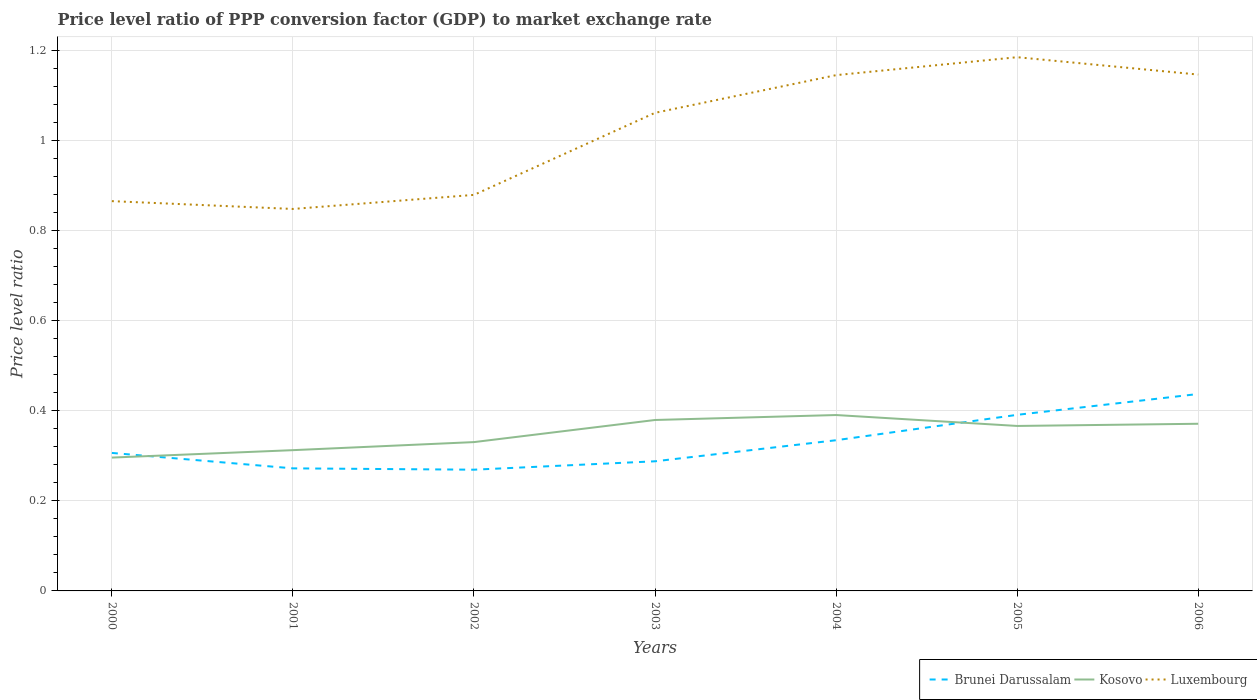Does the line corresponding to Kosovo intersect with the line corresponding to Brunei Darussalam?
Offer a terse response. Yes. Across all years, what is the maximum price level ratio in Luxembourg?
Give a very brief answer. 0.85. In which year was the price level ratio in Kosovo maximum?
Your answer should be compact. 2000. What is the total price level ratio in Kosovo in the graph?
Offer a very short reply. -0.03. What is the difference between the highest and the second highest price level ratio in Brunei Darussalam?
Make the answer very short. 0.17. What is the difference between the highest and the lowest price level ratio in Brunei Darussalam?
Ensure brevity in your answer.  3. Is the price level ratio in Luxembourg strictly greater than the price level ratio in Brunei Darussalam over the years?
Offer a very short reply. No. How many lines are there?
Offer a very short reply. 3. How many years are there in the graph?
Provide a short and direct response. 7. Where does the legend appear in the graph?
Make the answer very short. Bottom right. How are the legend labels stacked?
Offer a very short reply. Horizontal. What is the title of the graph?
Give a very brief answer. Price level ratio of PPP conversion factor (GDP) to market exchange rate. What is the label or title of the Y-axis?
Your answer should be compact. Price level ratio. What is the Price level ratio in Brunei Darussalam in 2000?
Make the answer very short. 0.31. What is the Price level ratio in Kosovo in 2000?
Make the answer very short. 0.3. What is the Price level ratio of Luxembourg in 2000?
Provide a short and direct response. 0.87. What is the Price level ratio in Brunei Darussalam in 2001?
Your answer should be very brief. 0.27. What is the Price level ratio in Kosovo in 2001?
Give a very brief answer. 0.31. What is the Price level ratio in Luxembourg in 2001?
Provide a succinct answer. 0.85. What is the Price level ratio of Brunei Darussalam in 2002?
Give a very brief answer. 0.27. What is the Price level ratio of Kosovo in 2002?
Your response must be concise. 0.33. What is the Price level ratio of Luxembourg in 2002?
Offer a terse response. 0.88. What is the Price level ratio of Brunei Darussalam in 2003?
Keep it short and to the point. 0.29. What is the Price level ratio of Kosovo in 2003?
Keep it short and to the point. 0.38. What is the Price level ratio of Luxembourg in 2003?
Ensure brevity in your answer.  1.06. What is the Price level ratio of Brunei Darussalam in 2004?
Keep it short and to the point. 0.33. What is the Price level ratio of Kosovo in 2004?
Your answer should be compact. 0.39. What is the Price level ratio of Luxembourg in 2004?
Offer a terse response. 1.15. What is the Price level ratio of Brunei Darussalam in 2005?
Keep it short and to the point. 0.39. What is the Price level ratio of Kosovo in 2005?
Offer a terse response. 0.37. What is the Price level ratio of Luxembourg in 2005?
Make the answer very short. 1.19. What is the Price level ratio in Brunei Darussalam in 2006?
Your answer should be very brief. 0.44. What is the Price level ratio in Kosovo in 2006?
Give a very brief answer. 0.37. What is the Price level ratio in Luxembourg in 2006?
Offer a very short reply. 1.15. Across all years, what is the maximum Price level ratio of Brunei Darussalam?
Provide a succinct answer. 0.44. Across all years, what is the maximum Price level ratio in Kosovo?
Your response must be concise. 0.39. Across all years, what is the maximum Price level ratio of Luxembourg?
Provide a short and direct response. 1.19. Across all years, what is the minimum Price level ratio in Brunei Darussalam?
Give a very brief answer. 0.27. Across all years, what is the minimum Price level ratio in Kosovo?
Give a very brief answer. 0.3. Across all years, what is the minimum Price level ratio in Luxembourg?
Provide a short and direct response. 0.85. What is the total Price level ratio in Brunei Darussalam in the graph?
Make the answer very short. 2.3. What is the total Price level ratio in Kosovo in the graph?
Your answer should be very brief. 2.45. What is the total Price level ratio of Luxembourg in the graph?
Give a very brief answer. 7.13. What is the difference between the Price level ratio in Brunei Darussalam in 2000 and that in 2001?
Your response must be concise. 0.03. What is the difference between the Price level ratio in Kosovo in 2000 and that in 2001?
Keep it short and to the point. -0.02. What is the difference between the Price level ratio in Luxembourg in 2000 and that in 2001?
Your response must be concise. 0.02. What is the difference between the Price level ratio in Brunei Darussalam in 2000 and that in 2002?
Your response must be concise. 0.04. What is the difference between the Price level ratio in Kosovo in 2000 and that in 2002?
Your answer should be very brief. -0.03. What is the difference between the Price level ratio of Luxembourg in 2000 and that in 2002?
Your answer should be compact. -0.01. What is the difference between the Price level ratio in Brunei Darussalam in 2000 and that in 2003?
Your answer should be very brief. 0.02. What is the difference between the Price level ratio of Kosovo in 2000 and that in 2003?
Make the answer very short. -0.08. What is the difference between the Price level ratio in Luxembourg in 2000 and that in 2003?
Your answer should be very brief. -0.2. What is the difference between the Price level ratio in Brunei Darussalam in 2000 and that in 2004?
Your response must be concise. -0.03. What is the difference between the Price level ratio in Kosovo in 2000 and that in 2004?
Ensure brevity in your answer.  -0.09. What is the difference between the Price level ratio of Luxembourg in 2000 and that in 2004?
Ensure brevity in your answer.  -0.28. What is the difference between the Price level ratio of Brunei Darussalam in 2000 and that in 2005?
Your answer should be very brief. -0.08. What is the difference between the Price level ratio in Kosovo in 2000 and that in 2005?
Your answer should be very brief. -0.07. What is the difference between the Price level ratio of Luxembourg in 2000 and that in 2005?
Your answer should be compact. -0.32. What is the difference between the Price level ratio of Brunei Darussalam in 2000 and that in 2006?
Offer a very short reply. -0.13. What is the difference between the Price level ratio in Kosovo in 2000 and that in 2006?
Provide a succinct answer. -0.08. What is the difference between the Price level ratio of Luxembourg in 2000 and that in 2006?
Provide a short and direct response. -0.28. What is the difference between the Price level ratio of Brunei Darussalam in 2001 and that in 2002?
Offer a terse response. 0. What is the difference between the Price level ratio in Kosovo in 2001 and that in 2002?
Your response must be concise. -0.02. What is the difference between the Price level ratio of Luxembourg in 2001 and that in 2002?
Offer a terse response. -0.03. What is the difference between the Price level ratio in Brunei Darussalam in 2001 and that in 2003?
Provide a short and direct response. -0.02. What is the difference between the Price level ratio of Kosovo in 2001 and that in 2003?
Provide a succinct answer. -0.07. What is the difference between the Price level ratio in Luxembourg in 2001 and that in 2003?
Ensure brevity in your answer.  -0.21. What is the difference between the Price level ratio in Brunei Darussalam in 2001 and that in 2004?
Offer a terse response. -0.06. What is the difference between the Price level ratio of Kosovo in 2001 and that in 2004?
Give a very brief answer. -0.08. What is the difference between the Price level ratio of Luxembourg in 2001 and that in 2004?
Offer a terse response. -0.3. What is the difference between the Price level ratio of Brunei Darussalam in 2001 and that in 2005?
Ensure brevity in your answer.  -0.12. What is the difference between the Price level ratio in Kosovo in 2001 and that in 2005?
Your answer should be very brief. -0.05. What is the difference between the Price level ratio in Luxembourg in 2001 and that in 2005?
Your answer should be very brief. -0.34. What is the difference between the Price level ratio in Brunei Darussalam in 2001 and that in 2006?
Offer a terse response. -0.17. What is the difference between the Price level ratio of Kosovo in 2001 and that in 2006?
Provide a short and direct response. -0.06. What is the difference between the Price level ratio in Luxembourg in 2001 and that in 2006?
Ensure brevity in your answer.  -0.3. What is the difference between the Price level ratio in Brunei Darussalam in 2002 and that in 2003?
Make the answer very short. -0.02. What is the difference between the Price level ratio of Kosovo in 2002 and that in 2003?
Keep it short and to the point. -0.05. What is the difference between the Price level ratio in Luxembourg in 2002 and that in 2003?
Your response must be concise. -0.18. What is the difference between the Price level ratio in Brunei Darussalam in 2002 and that in 2004?
Provide a succinct answer. -0.07. What is the difference between the Price level ratio in Kosovo in 2002 and that in 2004?
Your answer should be very brief. -0.06. What is the difference between the Price level ratio in Luxembourg in 2002 and that in 2004?
Keep it short and to the point. -0.27. What is the difference between the Price level ratio in Brunei Darussalam in 2002 and that in 2005?
Provide a short and direct response. -0.12. What is the difference between the Price level ratio of Kosovo in 2002 and that in 2005?
Keep it short and to the point. -0.04. What is the difference between the Price level ratio of Luxembourg in 2002 and that in 2005?
Give a very brief answer. -0.31. What is the difference between the Price level ratio in Brunei Darussalam in 2002 and that in 2006?
Provide a succinct answer. -0.17. What is the difference between the Price level ratio of Kosovo in 2002 and that in 2006?
Offer a very short reply. -0.04. What is the difference between the Price level ratio of Luxembourg in 2002 and that in 2006?
Keep it short and to the point. -0.27. What is the difference between the Price level ratio of Brunei Darussalam in 2003 and that in 2004?
Ensure brevity in your answer.  -0.05. What is the difference between the Price level ratio in Kosovo in 2003 and that in 2004?
Ensure brevity in your answer.  -0.01. What is the difference between the Price level ratio of Luxembourg in 2003 and that in 2004?
Keep it short and to the point. -0.08. What is the difference between the Price level ratio in Brunei Darussalam in 2003 and that in 2005?
Offer a terse response. -0.1. What is the difference between the Price level ratio of Kosovo in 2003 and that in 2005?
Provide a short and direct response. 0.01. What is the difference between the Price level ratio of Luxembourg in 2003 and that in 2005?
Keep it short and to the point. -0.12. What is the difference between the Price level ratio in Brunei Darussalam in 2003 and that in 2006?
Make the answer very short. -0.15. What is the difference between the Price level ratio in Kosovo in 2003 and that in 2006?
Your answer should be very brief. 0.01. What is the difference between the Price level ratio in Luxembourg in 2003 and that in 2006?
Provide a short and direct response. -0.09. What is the difference between the Price level ratio of Brunei Darussalam in 2004 and that in 2005?
Offer a very short reply. -0.06. What is the difference between the Price level ratio of Kosovo in 2004 and that in 2005?
Give a very brief answer. 0.02. What is the difference between the Price level ratio in Luxembourg in 2004 and that in 2005?
Make the answer very short. -0.04. What is the difference between the Price level ratio in Brunei Darussalam in 2004 and that in 2006?
Make the answer very short. -0.1. What is the difference between the Price level ratio of Kosovo in 2004 and that in 2006?
Ensure brevity in your answer.  0.02. What is the difference between the Price level ratio in Luxembourg in 2004 and that in 2006?
Offer a terse response. -0. What is the difference between the Price level ratio of Brunei Darussalam in 2005 and that in 2006?
Your answer should be compact. -0.05. What is the difference between the Price level ratio in Kosovo in 2005 and that in 2006?
Your response must be concise. -0. What is the difference between the Price level ratio in Luxembourg in 2005 and that in 2006?
Your response must be concise. 0.04. What is the difference between the Price level ratio in Brunei Darussalam in 2000 and the Price level ratio in Kosovo in 2001?
Provide a succinct answer. -0.01. What is the difference between the Price level ratio in Brunei Darussalam in 2000 and the Price level ratio in Luxembourg in 2001?
Your response must be concise. -0.54. What is the difference between the Price level ratio in Kosovo in 2000 and the Price level ratio in Luxembourg in 2001?
Offer a very short reply. -0.55. What is the difference between the Price level ratio in Brunei Darussalam in 2000 and the Price level ratio in Kosovo in 2002?
Your response must be concise. -0.02. What is the difference between the Price level ratio in Brunei Darussalam in 2000 and the Price level ratio in Luxembourg in 2002?
Offer a very short reply. -0.57. What is the difference between the Price level ratio in Kosovo in 2000 and the Price level ratio in Luxembourg in 2002?
Your answer should be compact. -0.58. What is the difference between the Price level ratio of Brunei Darussalam in 2000 and the Price level ratio of Kosovo in 2003?
Your response must be concise. -0.07. What is the difference between the Price level ratio in Brunei Darussalam in 2000 and the Price level ratio in Luxembourg in 2003?
Offer a very short reply. -0.76. What is the difference between the Price level ratio in Kosovo in 2000 and the Price level ratio in Luxembourg in 2003?
Make the answer very short. -0.77. What is the difference between the Price level ratio of Brunei Darussalam in 2000 and the Price level ratio of Kosovo in 2004?
Your answer should be very brief. -0.08. What is the difference between the Price level ratio in Brunei Darussalam in 2000 and the Price level ratio in Luxembourg in 2004?
Your answer should be compact. -0.84. What is the difference between the Price level ratio in Kosovo in 2000 and the Price level ratio in Luxembourg in 2004?
Your answer should be compact. -0.85. What is the difference between the Price level ratio in Brunei Darussalam in 2000 and the Price level ratio in Kosovo in 2005?
Ensure brevity in your answer.  -0.06. What is the difference between the Price level ratio in Brunei Darussalam in 2000 and the Price level ratio in Luxembourg in 2005?
Give a very brief answer. -0.88. What is the difference between the Price level ratio in Kosovo in 2000 and the Price level ratio in Luxembourg in 2005?
Offer a very short reply. -0.89. What is the difference between the Price level ratio in Brunei Darussalam in 2000 and the Price level ratio in Kosovo in 2006?
Keep it short and to the point. -0.06. What is the difference between the Price level ratio of Brunei Darussalam in 2000 and the Price level ratio of Luxembourg in 2006?
Ensure brevity in your answer.  -0.84. What is the difference between the Price level ratio of Kosovo in 2000 and the Price level ratio of Luxembourg in 2006?
Give a very brief answer. -0.85. What is the difference between the Price level ratio of Brunei Darussalam in 2001 and the Price level ratio of Kosovo in 2002?
Keep it short and to the point. -0.06. What is the difference between the Price level ratio of Brunei Darussalam in 2001 and the Price level ratio of Luxembourg in 2002?
Give a very brief answer. -0.61. What is the difference between the Price level ratio in Kosovo in 2001 and the Price level ratio in Luxembourg in 2002?
Make the answer very short. -0.57. What is the difference between the Price level ratio of Brunei Darussalam in 2001 and the Price level ratio of Kosovo in 2003?
Provide a short and direct response. -0.11. What is the difference between the Price level ratio of Brunei Darussalam in 2001 and the Price level ratio of Luxembourg in 2003?
Provide a succinct answer. -0.79. What is the difference between the Price level ratio of Kosovo in 2001 and the Price level ratio of Luxembourg in 2003?
Your answer should be very brief. -0.75. What is the difference between the Price level ratio in Brunei Darussalam in 2001 and the Price level ratio in Kosovo in 2004?
Offer a terse response. -0.12. What is the difference between the Price level ratio of Brunei Darussalam in 2001 and the Price level ratio of Luxembourg in 2004?
Your answer should be compact. -0.87. What is the difference between the Price level ratio of Kosovo in 2001 and the Price level ratio of Luxembourg in 2004?
Make the answer very short. -0.83. What is the difference between the Price level ratio in Brunei Darussalam in 2001 and the Price level ratio in Kosovo in 2005?
Give a very brief answer. -0.09. What is the difference between the Price level ratio of Brunei Darussalam in 2001 and the Price level ratio of Luxembourg in 2005?
Provide a succinct answer. -0.91. What is the difference between the Price level ratio of Kosovo in 2001 and the Price level ratio of Luxembourg in 2005?
Offer a very short reply. -0.87. What is the difference between the Price level ratio of Brunei Darussalam in 2001 and the Price level ratio of Kosovo in 2006?
Your answer should be very brief. -0.1. What is the difference between the Price level ratio in Brunei Darussalam in 2001 and the Price level ratio in Luxembourg in 2006?
Make the answer very short. -0.87. What is the difference between the Price level ratio in Kosovo in 2001 and the Price level ratio in Luxembourg in 2006?
Keep it short and to the point. -0.83. What is the difference between the Price level ratio of Brunei Darussalam in 2002 and the Price level ratio of Kosovo in 2003?
Make the answer very short. -0.11. What is the difference between the Price level ratio of Brunei Darussalam in 2002 and the Price level ratio of Luxembourg in 2003?
Your answer should be compact. -0.79. What is the difference between the Price level ratio in Kosovo in 2002 and the Price level ratio in Luxembourg in 2003?
Keep it short and to the point. -0.73. What is the difference between the Price level ratio in Brunei Darussalam in 2002 and the Price level ratio in Kosovo in 2004?
Offer a very short reply. -0.12. What is the difference between the Price level ratio in Brunei Darussalam in 2002 and the Price level ratio in Luxembourg in 2004?
Offer a very short reply. -0.88. What is the difference between the Price level ratio in Kosovo in 2002 and the Price level ratio in Luxembourg in 2004?
Provide a succinct answer. -0.81. What is the difference between the Price level ratio of Brunei Darussalam in 2002 and the Price level ratio of Kosovo in 2005?
Make the answer very short. -0.1. What is the difference between the Price level ratio in Brunei Darussalam in 2002 and the Price level ratio in Luxembourg in 2005?
Ensure brevity in your answer.  -0.92. What is the difference between the Price level ratio in Kosovo in 2002 and the Price level ratio in Luxembourg in 2005?
Provide a short and direct response. -0.85. What is the difference between the Price level ratio in Brunei Darussalam in 2002 and the Price level ratio in Kosovo in 2006?
Make the answer very short. -0.1. What is the difference between the Price level ratio in Brunei Darussalam in 2002 and the Price level ratio in Luxembourg in 2006?
Give a very brief answer. -0.88. What is the difference between the Price level ratio of Kosovo in 2002 and the Price level ratio of Luxembourg in 2006?
Ensure brevity in your answer.  -0.82. What is the difference between the Price level ratio in Brunei Darussalam in 2003 and the Price level ratio in Kosovo in 2004?
Ensure brevity in your answer.  -0.1. What is the difference between the Price level ratio in Brunei Darussalam in 2003 and the Price level ratio in Luxembourg in 2004?
Your answer should be compact. -0.86. What is the difference between the Price level ratio in Kosovo in 2003 and the Price level ratio in Luxembourg in 2004?
Provide a succinct answer. -0.77. What is the difference between the Price level ratio of Brunei Darussalam in 2003 and the Price level ratio of Kosovo in 2005?
Your response must be concise. -0.08. What is the difference between the Price level ratio of Brunei Darussalam in 2003 and the Price level ratio of Luxembourg in 2005?
Make the answer very short. -0.9. What is the difference between the Price level ratio of Kosovo in 2003 and the Price level ratio of Luxembourg in 2005?
Provide a succinct answer. -0.81. What is the difference between the Price level ratio of Brunei Darussalam in 2003 and the Price level ratio of Kosovo in 2006?
Your answer should be very brief. -0.08. What is the difference between the Price level ratio of Brunei Darussalam in 2003 and the Price level ratio of Luxembourg in 2006?
Make the answer very short. -0.86. What is the difference between the Price level ratio of Kosovo in 2003 and the Price level ratio of Luxembourg in 2006?
Your answer should be compact. -0.77. What is the difference between the Price level ratio of Brunei Darussalam in 2004 and the Price level ratio of Kosovo in 2005?
Ensure brevity in your answer.  -0.03. What is the difference between the Price level ratio in Brunei Darussalam in 2004 and the Price level ratio in Luxembourg in 2005?
Give a very brief answer. -0.85. What is the difference between the Price level ratio in Kosovo in 2004 and the Price level ratio in Luxembourg in 2005?
Your answer should be compact. -0.79. What is the difference between the Price level ratio of Brunei Darussalam in 2004 and the Price level ratio of Kosovo in 2006?
Offer a terse response. -0.04. What is the difference between the Price level ratio in Brunei Darussalam in 2004 and the Price level ratio in Luxembourg in 2006?
Keep it short and to the point. -0.81. What is the difference between the Price level ratio in Kosovo in 2004 and the Price level ratio in Luxembourg in 2006?
Keep it short and to the point. -0.76. What is the difference between the Price level ratio in Brunei Darussalam in 2005 and the Price level ratio in Kosovo in 2006?
Make the answer very short. 0.02. What is the difference between the Price level ratio of Brunei Darussalam in 2005 and the Price level ratio of Luxembourg in 2006?
Offer a very short reply. -0.76. What is the difference between the Price level ratio in Kosovo in 2005 and the Price level ratio in Luxembourg in 2006?
Provide a short and direct response. -0.78. What is the average Price level ratio in Brunei Darussalam per year?
Your answer should be compact. 0.33. What is the average Price level ratio in Kosovo per year?
Provide a short and direct response. 0.35. What is the average Price level ratio in Luxembourg per year?
Offer a terse response. 1.02. In the year 2000, what is the difference between the Price level ratio of Brunei Darussalam and Price level ratio of Kosovo?
Your response must be concise. 0.01. In the year 2000, what is the difference between the Price level ratio of Brunei Darussalam and Price level ratio of Luxembourg?
Give a very brief answer. -0.56. In the year 2000, what is the difference between the Price level ratio in Kosovo and Price level ratio in Luxembourg?
Provide a succinct answer. -0.57. In the year 2001, what is the difference between the Price level ratio of Brunei Darussalam and Price level ratio of Kosovo?
Provide a succinct answer. -0.04. In the year 2001, what is the difference between the Price level ratio in Brunei Darussalam and Price level ratio in Luxembourg?
Your answer should be compact. -0.58. In the year 2001, what is the difference between the Price level ratio of Kosovo and Price level ratio of Luxembourg?
Ensure brevity in your answer.  -0.54. In the year 2002, what is the difference between the Price level ratio of Brunei Darussalam and Price level ratio of Kosovo?
Provide a short and direct response. -0.06. In the year 2002, what is the difference between the Price level ratio in Brunei Darussalam and Price level ratio in Luxembourg?
Provide a short and direct response. -0.61. In the year 2002, what is the difference between the Price level ratio in Kosovo and Price level ratio in Luxembourg?
Make the answer very short. -0.55. In the year 2003, what is the difference between the Price level ratio in Brunei Darussalam and Price level ratio in Kosovo?
Ensure brevity in your answer.  -0.09. In the year 2003, what is the difference between the Price level ratio of Brunei Darussalam and Price level ratio of Luxembourg?
Your answer should be very brief. -0.77. In the year 2003, what is the difference between the Price level ratio in Kosovo and Price level ratio in Luxembourg?
Your response must be concise. -0.68. In the year 2004, what is the difference between the Price level ratio of Brunei Darussalam and Price level ratio of Kosovo?
Provide a short and direct response. -0.06. In the year 2004, what is the difference between the Price level ratio of Brunei Darussalam and Price level ratio of Luxembourg?
Keep it short and to the point. -0.81. In the year 2004, what is the difference between the Price level ratio in Kosovo and Price level ratio in Luxembourg?
Your response must be concise. -0.75. In the year 2005, what is the difference between the Price level ratio of Brunei Darussalam and Price level ratio of Kosovo?
Keep it short and to the point. 0.02. In the year 2005, what is the difference between the Price level ratio of Brunei Darussalam and Price level ratio of Luxembourg?
Ensure brevity in your answer.  -0.79. In the year 2005, what is the difference between the Price level ratio of Kosovo and Price level ratio of Luxembourg?
Ensure brevity in your answer.  -0.82. In the year 2006, what is the difference between the Price level ratio in Brunei Darussalam and Price level ratio in Kosovo?
Offer a terse response. 0.07. In the year 2006, what is the difference between the Price level ratio of Brunei Darussalam and Price level ratio of Luxembourg?
Provide a short and direct response. -0.71. In the year 2006, what is the difference between the Price level ratio of Kosovo and Price level ratio of Luxembourg?
Give a very brief answer. -0.78. What is the ratio of the Price level ratio in Brunei Darussalam in 2000 to that in 2001?
Your response must be concise. 1.13. What is the ratio of the Price level ratio in Kosovo in 2000 to that in 2001?
Give a very brief answer. 0.95. What is the ratio of the Price level ratio in Luxembourg in 2000 to that in 2001?
Make the answer very short. 1.02. What is the ratio of the Price level ratio of Brunei Darussalam in 2000 to that in 2002?
Your answer should be compact. 1.14. What is the ratio of the Price level ratio in Kosovo in 2000 to that in 2002?
Your answer should be compact. 0.9. What is the ratio of the Price level ratio of Luxembourg in 2000 to that in 2002?
Give a very brief answer. 0.98. What is the ratio of the Price level ratio of Brunei Darussalam in 2000 to that in 2003?
Your answer should be compact. 1.06. What is the ratio of the Price level ratio of Kosovo in 2000 to that in 2003?
Provide a short and direct response. 0.78. What is the ratio of the Price level ratio of Luxembourg in 2000 to that in 2003?
Make the answer very short. 0.82. What is the ratio of the Price level ratio of Brunei Darussalam in 2000 to that in 2004?
Offer a terse response. 0.92. What is the ratio of the Price level ratio of Kosovo in 2000 to that in 2004?
Ensure brevity in your answer.  0.76. What is the ratio of the Price level ratio in Luxembourg in 2000 to that in 2004?
Your answer should be very brief. 0.76. What is the ratio of the Price level ratio of Brunei Darussalam in 2000 to that in 2005?
Provide a succinct answer. 0.78. What is the ratio of the Price level ratio in Kosovo in 2000 to that in 2005?
Your answer should be very brief. 0.81. What is the ratio of the Price level ratio in Luxembourg in 2000 to that in 2005?
Your answer should be very brief. 0.73. What is the ratio of the Price level ratio of Brunei Darussalam in 2000 to that in 2006?
Offer a very short reply. 0.7. What is the ratio of the Price level ratio of Kosovo in 2000 to that in 2006?
Offer a terse response. 0.8. What is the ratio of the Price level ratio of Luxembourg in 2000 to that in 2006?
Give a very brief answer. 0.75. What is the ratio of the Price level ratio in Brunei Darussalam in 2001 to that in 2002?
Provide a short and direct response. 1.01. What is the ratio of the Price level ratio of Kosovo in 2001 to that in 2002?
Provide a short and direct response. 0.95. What is the ratio of the Price level ratio of Luxembourg in 2001 to that in 2002?
Provide a succinct answer. 0.96. What is the ratio of the Price level ratio of Brunei Darussalam in 2001 to that in 2003?
Ensure brevity in your answer.  0.95. What is the ratio of the Price level ratio in Kosovo in 2001 to that in 2003?
Provide a short and direct response. 0.82. What is the ratio of the Price level ratio of Luxembourg in 2001 to that in 2003?
Keep it short and to the point. 0.8. What is the ratio of the Price level ratio in Brunei Darussalam in 2001 to that in 2004?
Your response must be concise. 0.81. What is the ratio of the Price level ratio of Kosovo in 2001 to that in 2004?
Your answer should be very brief. 0.8. What is the ratio of the Price level ratio of Luxembourg in 2001 to that in 2004?
Offer a very short reply. 0.74. What is the ratio of the Price level ratio in Brunei Darussalam in 2001 to that in 2005?
Provide a succinct answer. 0.7. What is the ratio of the Price level ratio in Kosovo in 2001 to that in 2005?
Provide a short and direct response. 0.85. What is the ratio of the Price level ratio in Luxembourg in 2001 to that in 2005?
Your answer should be very brief. 0.72. What is the ratio of the Price level ratio in Brunei Darussalam in 2001 to that in 2006?
Make the answer very short. 0.62. What is the ratio of the Price level ratio in Kosovo in 2001 to that in 2006?
Keep it short and to the point. 0.84. What is the ratio of the Price level ratio in Luxembourg in 2001 to that in 2006?
Provide a succinct answer. 0.74. What is the ratio of the Price level ratio in Brunei Darussalam in 2002 to that in 2003?
Make the answer very short. 0.94. What is the ratio of the Price level ratio in Kosovo in 2002 to that in 2003?
Your answer should be compact. 0.87. What is the ratio of the Price level ratio of Luxembourg in 2002 to that in 2003?
Offer a very short reply. 0.83. What is the ratio of the Price level ratio in Brunei Darussalam in 2002 to that in 2004?
Your response must be concise. 0.8. What is the ratio of the Price level ratio of Kosovo in 2002 to that in 2004?
Your response must be concise. 0.85. What is the ratio of the Price level ratio in Luxembourg in 2002 to that in 2004?
Offer a very short reply. 0.77. What is the ratio of the Price level ratio of Brunei Darussalam in 2002 to that in 2005?
Give a very brief answer. 0.69. What is the ratio of the Price level ratio of Kosovo in 2002 to that in 2005?
Provide a succinct answer. 0.9. What is the ratio of the Price level ratio in Luxembourg in 2002 to that in 2005?
Provide a succinct answer. 0.74. What is the ratio of the Price level ratio in Brunei Darussalam in 2002 to that in 2006?
Keep it short and to the point. 0.62. What is the ratio of the Price level ratio of Kosovo in 2002 to that in 2006?
Provide a succinct answer. 0.89. What is the ratio of the Price level ratio of Luxembourg in 2002 to that in 2006?
Keep it short and to the point. 0.77. What is the ratio of the Price level ratio in Brunei Darussalam in 2003 to that in 2004?
Ensure brevity in your answer.  0.86. What is the ratio of the Price level ratio in Kosovo in 2003 to that in 2004?
Ensure brevity in your answer.  0.97. What is the ratio of the Price level ratio of Luxembourg in 2003 to that in 2004?
Offer a very short reply. 0.93. What is the ratio of the Price level ratio in Brunei Darussalam in 2003 to that in 2005?
Provide a short and direct response. 0.74. What is the ratio of the Price level ratio in Kosovo in 2003 to that in 2005?
Your answer should be very brief. 1.04. What is the ratio of the Price level ratio in Luxembourg in 2003 to that in 2005?
Make the answer very short. 0.9. What is the ratio of the Price level ratio in Brunei Darussalam in 2003 to that in 2006?
Your answer should be compact. 0.66. What is the ratio of the Price level ratio in Kosovo in 2003 to that in 2006?
Your answer should be compact. 1.02. What is the ratio of the Price level ratio in Luxembourg in 2003 to that in 2006?
Provide a short and direct response. 0.93. What is the ratio of the Price level ratio in Brunei Darussalam in 2004 to that in 2005?
Offer a terse response. 0.86. What is the ratio of the Price level ratio in Kosovo in 2004 to that in 2005?
Provide a succinct answer. 1.07. What is the ratio of the Price level ratio in Luxembourg in 2004 to that in 2005?
Give a very brief answer. 0.97. What is the ratio of the Price level ratio of Brunei Darussalam in 2004 to that in 2006?
Provide a short and direct response. 0.77. What is the ratio of the Price level ratio of Kosovo in 2004 to that in 2006?
Your answer should be compact. 1.05. What is the ratio of the Price level ratio of Brunei Darussalam in 2005 to that in 2006?
Your response must be concise. 0.89. What is the ratio of the Price level ratio in Kosovo in 2005 to that in 2006?
Your response must be concise. 0.99. What is the ratio of the Price level ratio of Luxembourg in 2005 to that in 2006?
Your answer should be very brief. 1.03. What is the difference between the highest and the second highest Price level ratio of Brunei Darussalam?
Provide a short and direct response. 0.05. What is the difference between the highest and the second highest Price level ratio of Kosovo?
Your answer should be very brief. 0.01. What is the difference between the highest and the second highest Price level ratio of Luxembourg?
Provide a succinct answer. 0.04. What is the difference between the highest and the lowest Price level ratio in Brunei Darussalam?
Provide a short and direct response. 0.17. What is the difference between the highest and the lowest Price level ratio of Kosovo?
Make the answer very short. 0.09. What is the difference between the highest and the lowest Price level ratio in Luxembourg?
Offer a terse response. 0.34. 